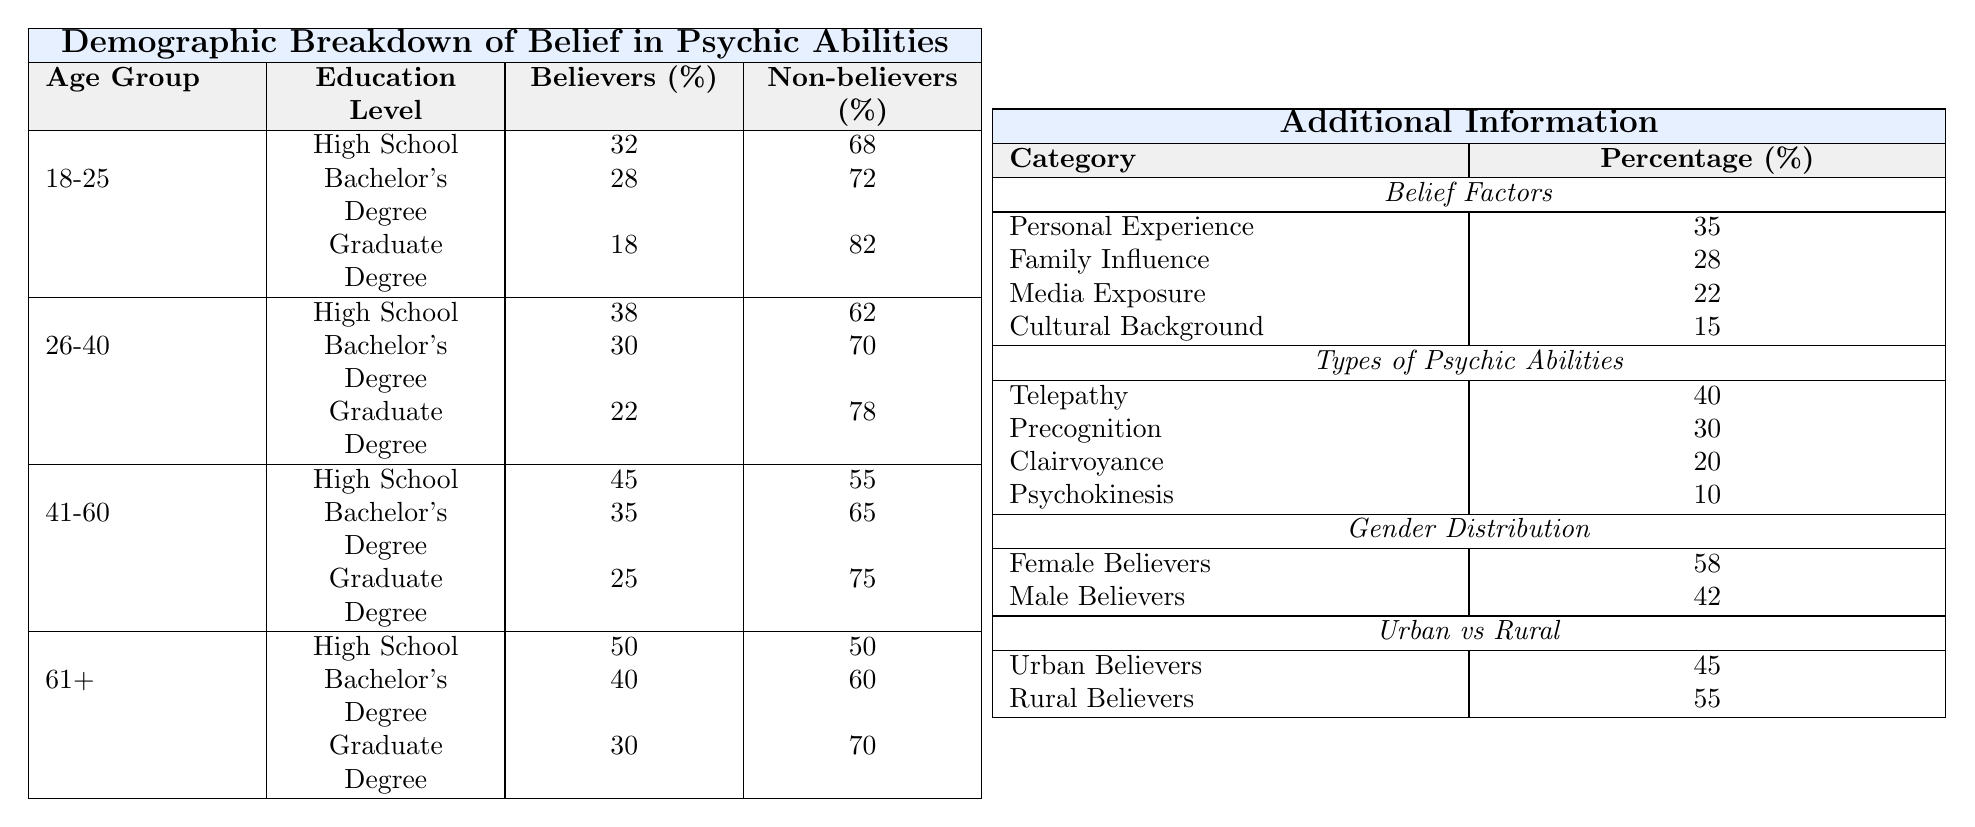What percentage of believers in psychic abilities are from the age group 41-60 with a Bachelor's Degree? From the table, in the age group 41-60 with a Bachelor's Degree, the percentage of believers is 35%.
Answer: 35% Which age group has the highest percentage of believers with a Graduate Degree? The age group 41-60 has the highest percentage of believers with a Graduate Degree at 25%.
Answer: 25% What is the difference in the percentage of believers between High School graduates in the 61+ age group and those in the 18-25 age group? In the 61+ age group, 50% are believers with a High School education, while in the 18-25 age group, 32% are believers. The difference is 50% - 32% = 18%.
Answer: 18% Is it true that there are more believers in psychic abilities in rural areas than in urban areas? According to the data, there are 55% rural believers and 45% urban believers, so it is true that there are more believers in rural areas.
Answer: Yes What is the average percentage of believers across all education levels for the age group 26-40? For the age group 26-40, the percentages of believers are 38% (High School), 30% (Bachelor's), and 22% (Graduate). Summing these gives: 38 + 30 + 22 = 90%. Dividing by the number of education levels (3) gives an average of 90% / 3 = 30%.
Answer: 30% Which education level has the highest percentage of non-believers in the age group 41-60? In the age group 41-60, the percentage of non-believers for High School is 55%, for Bachelor's Degree is 65%, and for Graduate Degree is 75%. The highest percentage of non-believers is with a Graduate Degree at 75%.
Answer: 75% How much percentage of believers is influenced by personal experience compared to those influenced by media exposure? Personal experience influences 35% of believers, while media exposure influences 22%. The difference is 35% - 22% = 13%.
Answer: 13% What percentage of believers are there in the age group 18-25 with a Graduate Degree? For the age group 18-25 with a Graduate Degree, the percentage of believers is 18%.
Answer: 18% In the 41-60 age group, what is the percentage of undecided individuals with a High School education? In the age group 41-60 with a High School education, the percentage of undecided individuals is 15%.
Answer: 15% How does the percentage of female believers compare to male believers in total? The percentage of female believers is 58% and male believers is 42%. Thus, females make up a higher percentage of believers than males by 58% - 42% = 16%.
Answer: 16% What can be inferred about the belief in psychic abilities as age increases? As age increases from 18-25 to 61+, the percentage of believers generally increases for High School and Bachelor's degrees, indicating a trend of higher belief with age, with the 61+ group having the highest believer percentage in High School and Bachelor's categories.
Answer: Generally increases 